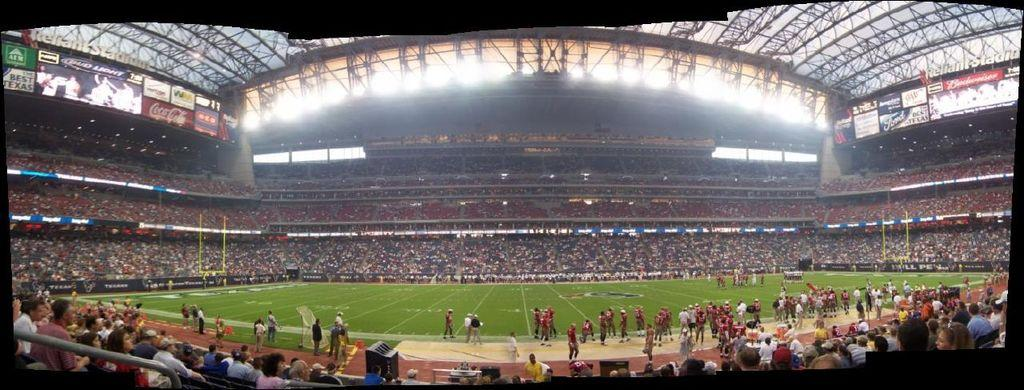What is the main setting of the image? The main setting of the image is a stadium. What feature of the stadium is mentioned in the facts? The stadium has a roof and is equipped with lights, hoardings, and screens. What can be observed about the people in the image? There are persons on the ground of the stadium, and there are also persons around the stadium's ground. What language is being spoken by the pot in the image? There is no pot present in the image, and therefore no language being spoken by it. Can you describe the curve of the hoardings in the image? The facts do not mention any specific curves or shapes of the hoardings in the image. 